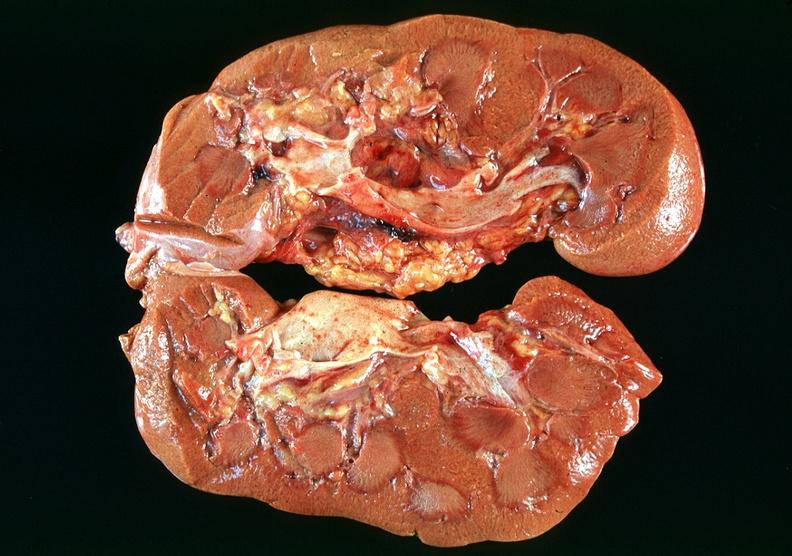why does this image show kidney, acute tubular necrosis?
Answer the question using a single word or phrase. Due to coagulopathy disseminated intravascular coagulation dic and shock alpha-1 antitrypsin deficiency 